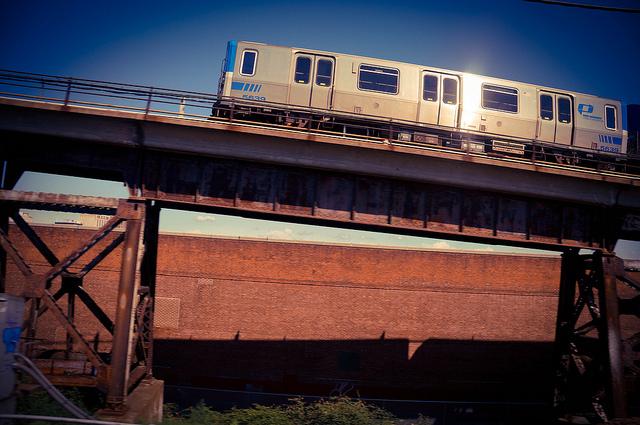What numbers are on the train?
Give a very brief answer. 5639. Is the train facing the camera?
Be succinct. No. What color are the rails?
Keep it brief. Brown. How many windows can be seen on the train car?
Be succinct. 10. What color is the train on the tracks?
Write a very short answer. Silver. Is the bridge over water?
Be succinct. No. What vehicle is visible on the elevated tracks?
Answer briefly. Train. How many people are in the carrier?
Be succinct. 0. Is the train moving?
Be succinct. Yes. 